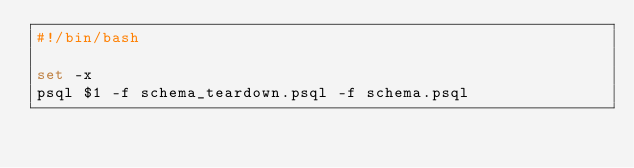<code> <loc_0><loc_0><loc_500><loc_500><_Bash_>#!/bin/bash

set -x
psql $1 -f schema_teardown.psql -f schema.psql
</code> 